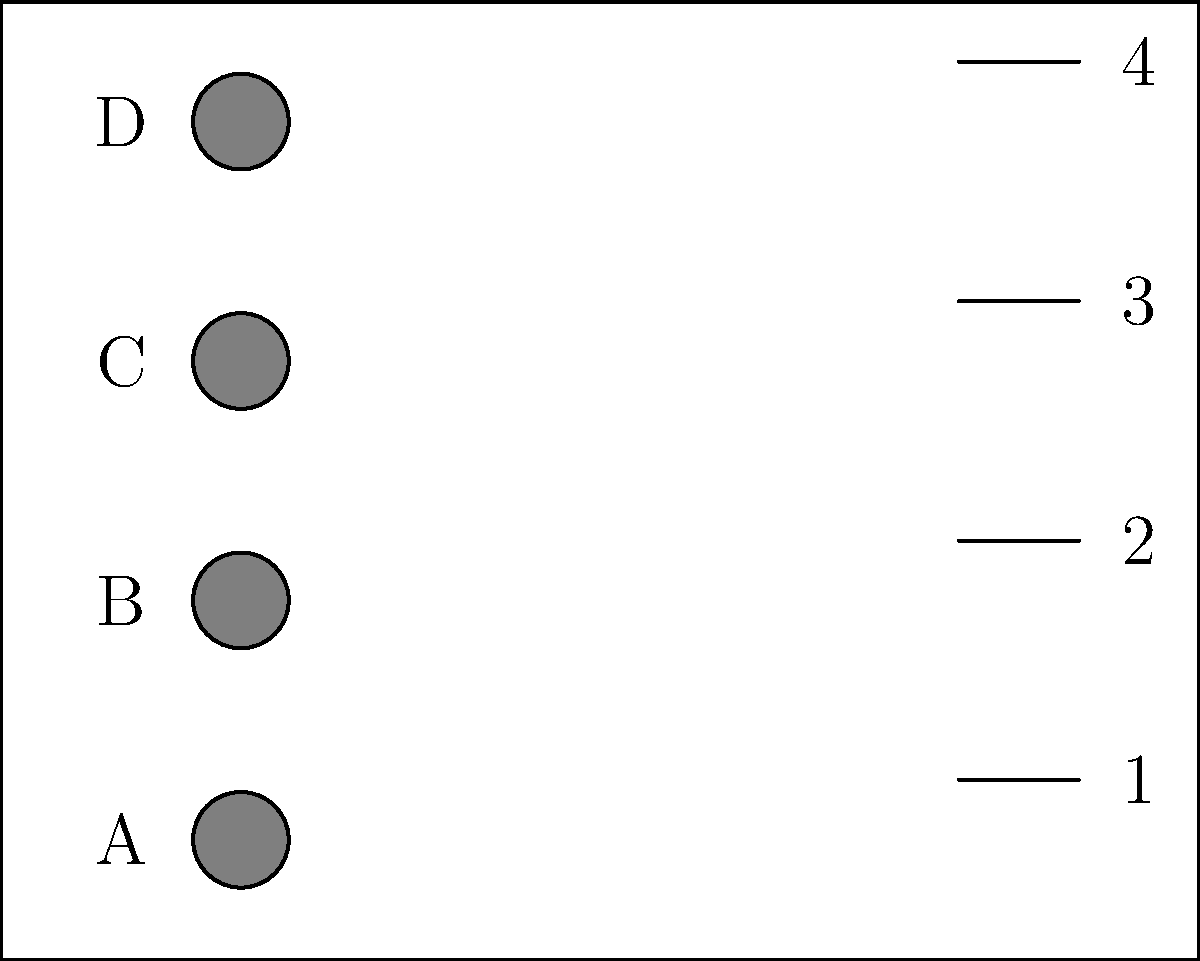Based on the 2D blueprint of a commercial restroom shown above, which arrangement of toilets and sinks would be most efficient for user flow and accessibility? Consider that the door is located on the left side of the room. To determine the optimal arrangement, we need to consider several factors:

1. User flow: The layout should allow for easy movement within the restroom.
2. Accessibility: At least one toilet and sink should be easily accessible for people with disabilities.
3. Privacy: Toilets should be placed away from the entrance for user comfort.
4. Efficient use of space: The arrangement should maximize the use of available space.

Step-by-step analysis:

1. Door location: The door is on the left side, so we should keep the area near it clear for easy entry and exit.

2. Toilet placement:
   - Toilet D is closest to the door, making it less private and potentially obstructing entry.
   - Toilets A and B are farthest from the door, offering more privacy.
   - Toilet C is in the middle, balancing privacy and accessibility.

3. Sink placement:
   - Sinks should be placed on the opposite side of the toilets to create a logical flow.
   - Sink 4 is closest to the door, making it easily accessible upon entry or exit.
   - Sinks 1 and 2 are farthest from the door, which may cause congestion.

4. Accessibility considerations:
   - An accessible toilet and sink should be near the entrance but not immediately next to it.
   - Toilet C and Sink 3 or 4 would be suitable for accessibility purposes.

5. Efficient space use:
   - Using toilets A, B, and C with sinks 2, 3, and 4 provides a good balance of space utilization.

Considering all these factors, the optimal arrangement would be:
- Use toilets A, B, and C
- Use sinks 2, 3, and 4

This arrangement provides privacy for toilets, efficient user flow, accessibility near the entrance (toilet C and sink 3), and good use of space.
Answer: Toilets A, B, C; Sinks 2, 3, 4 